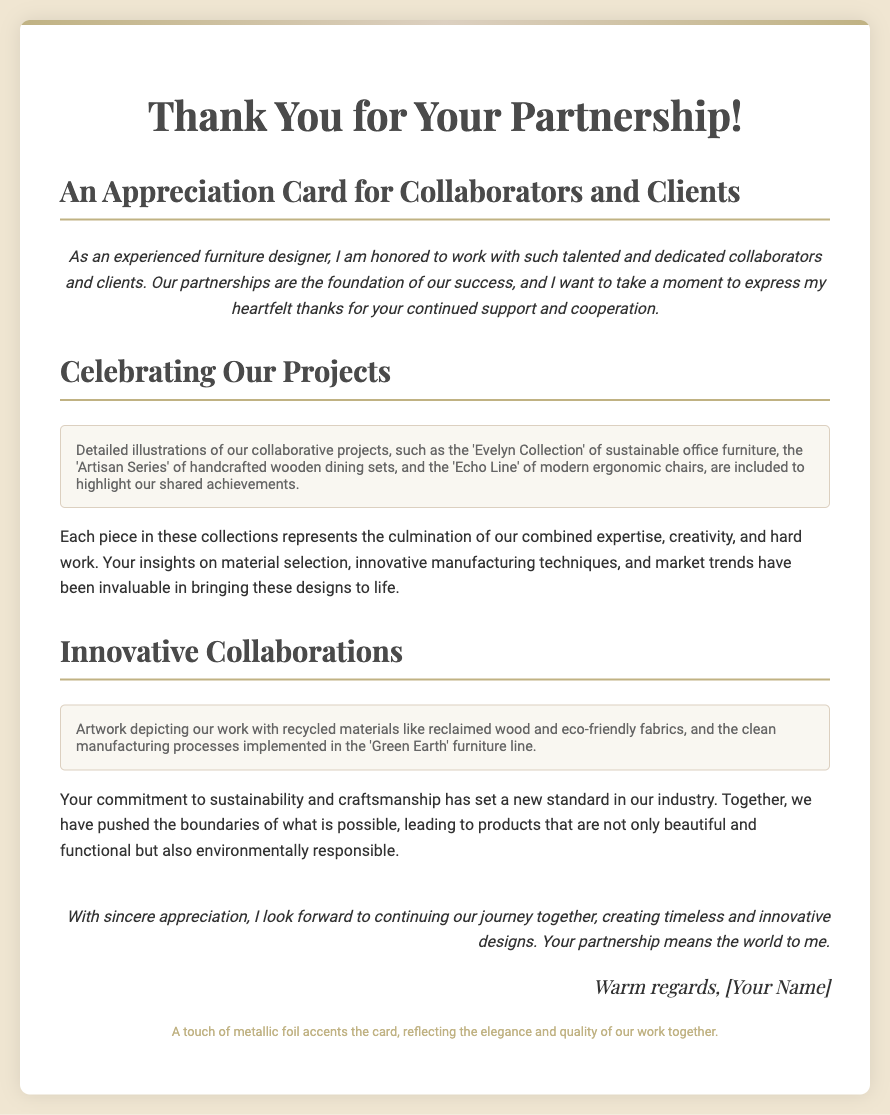What is the title of the card? The title is specified in the document as the main heading at the top of the card.
Answer: Thank You for Your Partnership! What collection is mentioned first in the project section? The first collection mentioned is part of the detailed illustrations aimed at showcasing shared achievements.
Answer: Evelyn Collection What type of materials are focused on in the 'Green Earth' furniture line? The document highlights specific materials that reflect sustainable practices in furniture design.
Answer: Recycled materials How many sections are dedicated to collaborative projects in total? The document includes two distinct sections celebrating different aspects of collaboration.
Answer: Two What does the metallic foil represent? The metallic foil is described in the context of enhancing the aesthetic quality of the card and the work involved.
Answer: Elegance and quality Who is expressing appreciation in the card? The card includes a signature line that indicates who is thanking the partners and clients.
Answer: [Your Name] 